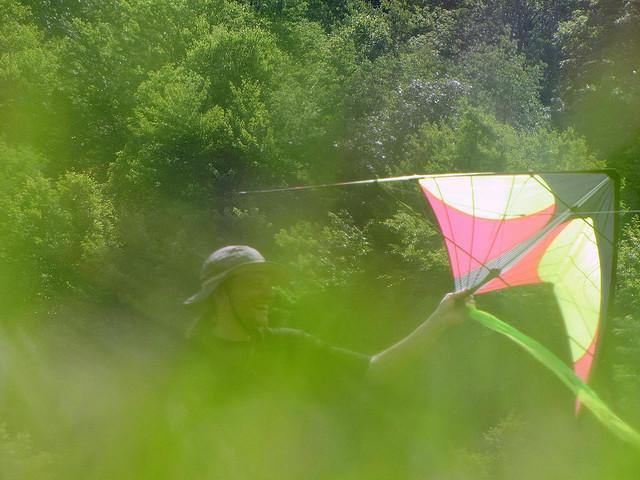How many clock hands are there?
Give a very brief answer. 0. 